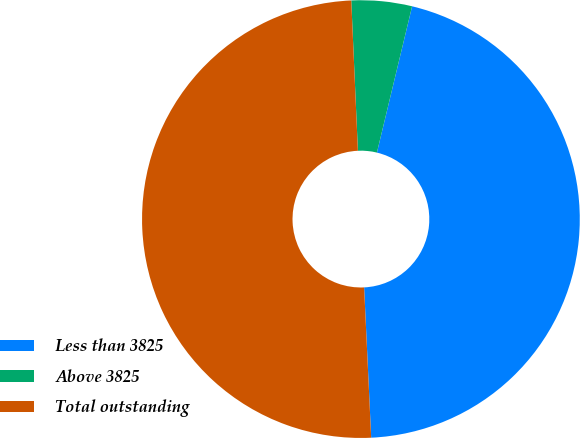<chart> <loc_0><loc_0><loc_500><loc_500><pie_chart><fcel>Less than 3825<fcel>Above 3825<fcel>Total outstanding<nl><fcel>45.5%<fcel>4.46%<fcel>50.05%<nl></chart> 